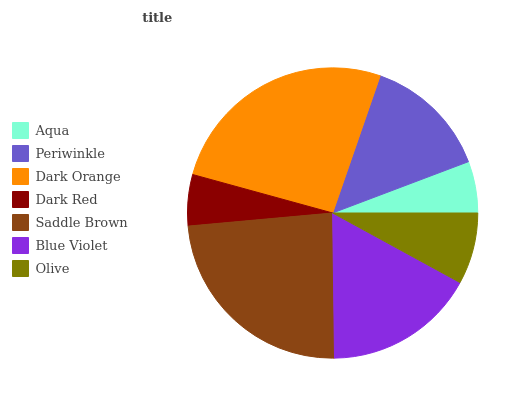Is Dark Red the minimum?
Answer yes or no. Yes. Is Dark Orange the maximum?
Answer yes or no. Yes. Is Periwinkle the minimum?
Answer yes or no. No. Is Periwinkle the maximum?
Answer yes or no. No. Is Periwinkle greater than Aqua?
Answer yes or no. Yes. Is Aqua less than Periwinkle?
Answer yes or no. Yes. Is Aqua greater than Periwinkle?
Answer yes or no. No. Is Periwinkle less than Aqua?
Answer yes or no. No. Is Periwinkle the high median?
Answer yes or no. Yes. Is Periwinkle the low median?
Answer yes or no. Yes. Is Saddle Brown the high median?
Answer yes or no. No. Is Blue Violet the low median?
Answer yes or no. No. 